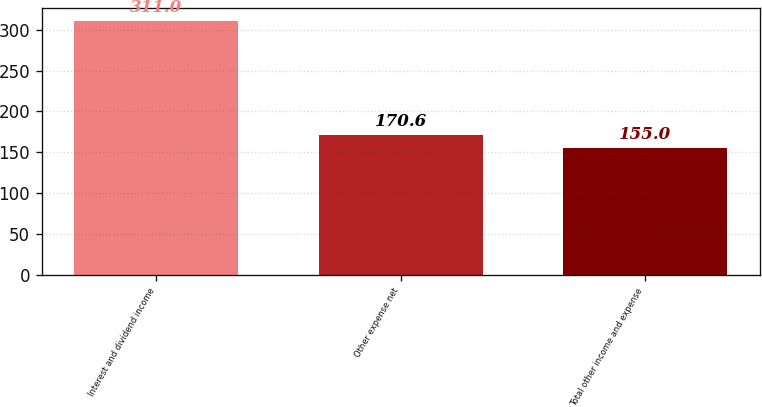Convert chart to OTSL. <chart><loc_0><loc_0><loc_500><loc_500><bar_chart><fcel>Interest and dividend income<fcel>Other expense net<fcel>Total other income and expense<nl><fcel>311<fcel>170.6<fcel>155<nl></chart> 